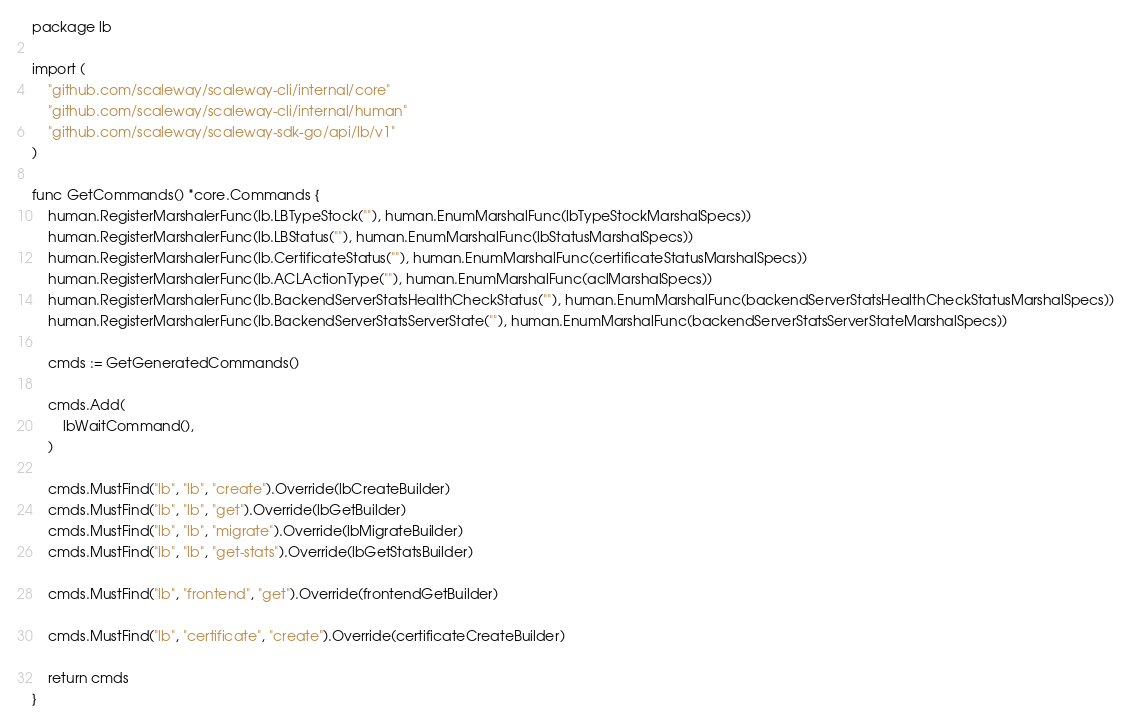<code> <loc_0><loc_0><loc_500><loc_500><_Go_>package lb

import (
	"github.com/scaleway/scaleway-cli/internal/core"
	"github.com/scaleway/scaleway-cli/internal/human"
	"github.com/scaleway/scaleway-sdk-go/api/lb/v1"
)

func GetCommands() *core.Commands {
	human.RegisterMarshalerFunc(lb.LBTypeStock(""), human.EnumMarshalFunc(lbTypeStockMarshalSpecs))
	human.RegisterMarshalerFunc(lb.LBStatus(""), human.EnumMarshalFunc(lbStatusMarshalSpecs))
	human.RegisterMarshalerFunc(lb.CertificateStatus(""), human.EnumMarshalFunc(certificateStatusMarshalSpecs))
	human.RegisterMarshalerFunc(lb.ACLActionType(""), human.EnumMarshalFunc(aclMarshalSpecs))
	human.RegisterMarshalerFunc(lb.BackendServerStatsHealthCheckStatus(""), human.EnumMarshalFunc(backendServerStatsHealthCheckStatusMarshalSpecs))
	human.RegisterMarshalerFunc(lb.BackendServerStatsServerState(""), human.EnumMarshalFunc(backendServerStatsServerStateMarshalSpecs))

	cmds := GetGeneratedCommands()

	cmds.Add(
		lbWaitCommand(),
	)

	cmds.MustFind("lb", "lb", "create").Override(lbCreateBuilder)
	cmds.MustFind("lb", "lb", "get").Override(lbGetBuilder)
	cmds.MustFind("lb", "lb", "migrate").Override(lbMigrateBuilder)
	cmds.MustFind("lb", "lb", "get-stats").Override(lbGetStatsBuilder)

	cmds.MustFind("lb", "frontend", "get").Override(frontendGetBuilder)

	cmds.MustFind("lb", "certificate", "create").Override(certificateCreateBuilder)

	return cmds
}
</code> 